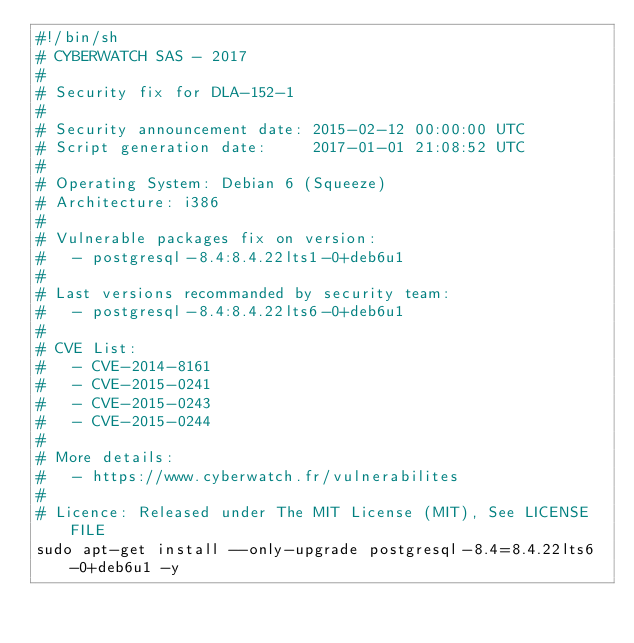<code> <loc_0><loc_0><loc_500><loc_500><_Bash_>#!/bin/sh
# CYBERWATCH SAS - 2017
#
# Security fix for DLA-152-1
#
# Security announcement date: 2015-02-12 00:00:00 UTC
# Script generation date:     2017-01-01 21:08:52 UTC
#
# Operating System: Debian 6 (Squeeze)
# Architecture: i386
#
# Vulnerable packages fix on version:
#   - postgresql-8.4:8.4.22lts1-0+deb6u1
#
# Last versions recommanded by security team:
#   - postgresql-8.4:8.4.22lts6-0+deb6u1
#
# CVE List:
#   - CVE-2014-8161
#   - CVE-2015-0241
#   - CVE-2015-0243
#   - CVE-2015-0244
#
# More details:
#   - https://www.cyberwatch.fr/vulnerabilites
#
# Licence: Released under The MIT License (MIT), See LICENSE FILE
sudo apt-get install --only-upgrade postgresql-8.4=8.4.22lts6-0+deb6u1 -y
</code> 